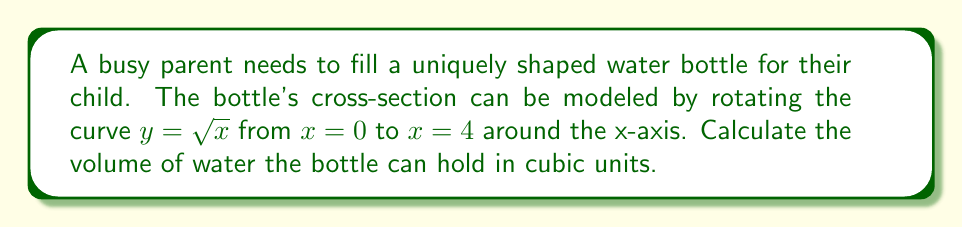Can you solve this math problem? To find the volume of a solid formed by rotating a curve around the x-axis, we use the washer method:

1. The volume is given by the integral: $V = \pi \int_a^b [f(x)]^2 dx$

2. In this case, $f(x) = \sqrt{x}$, $a = 0$, and $b = 4$

3. Substituting these values:
   $V = \pi \int_0^4 (\sqrt{x})^2 dx$

4. Simplify the integrand:
   $V = \pi \int_0^4 x dx$

5. Integrate:
   $V = \pi [\frac{1}{2}x^2]_0^4$

6. Evaluate the integral:
   $V = \pi (\frac{1}{2}(4^2) - \frac{1}{2}(0^2))$
   $V = \pi (8 - 0)$
   $V = 8\pi$

Therefore, the volume of the water bottle is $8\pi$ cubic units.
Answer: $8\pi$ cubic units 